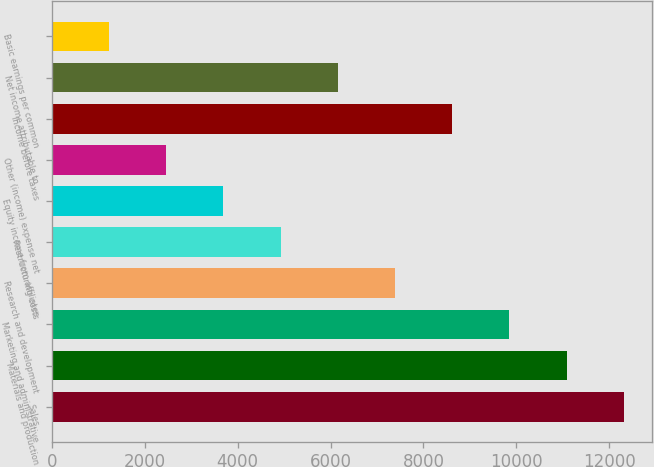Convert chart. <chart><loc_0><loc_0><loc_500><loc_500><bar_chart><fcel>Sales<fcel>Materials and production<fcel>Marketing and administrative<fcel>Research and development<fcel>Restructuring costs<fcel>Equity income from affiliates<fcel>Other (income) expense net<fcel>Income before taxes<fcel>Net income attributable to<fcel>Basic earnings per common<nl><fcel>12311<fcel>11079.9<fcel>9848.9<fcel>7386.82<fcel>4924.74<fcel>3693.7<fcel>2462.66<fcel>8617.86<fcel>6155.78<fcel>1231.62<nl></chart> 